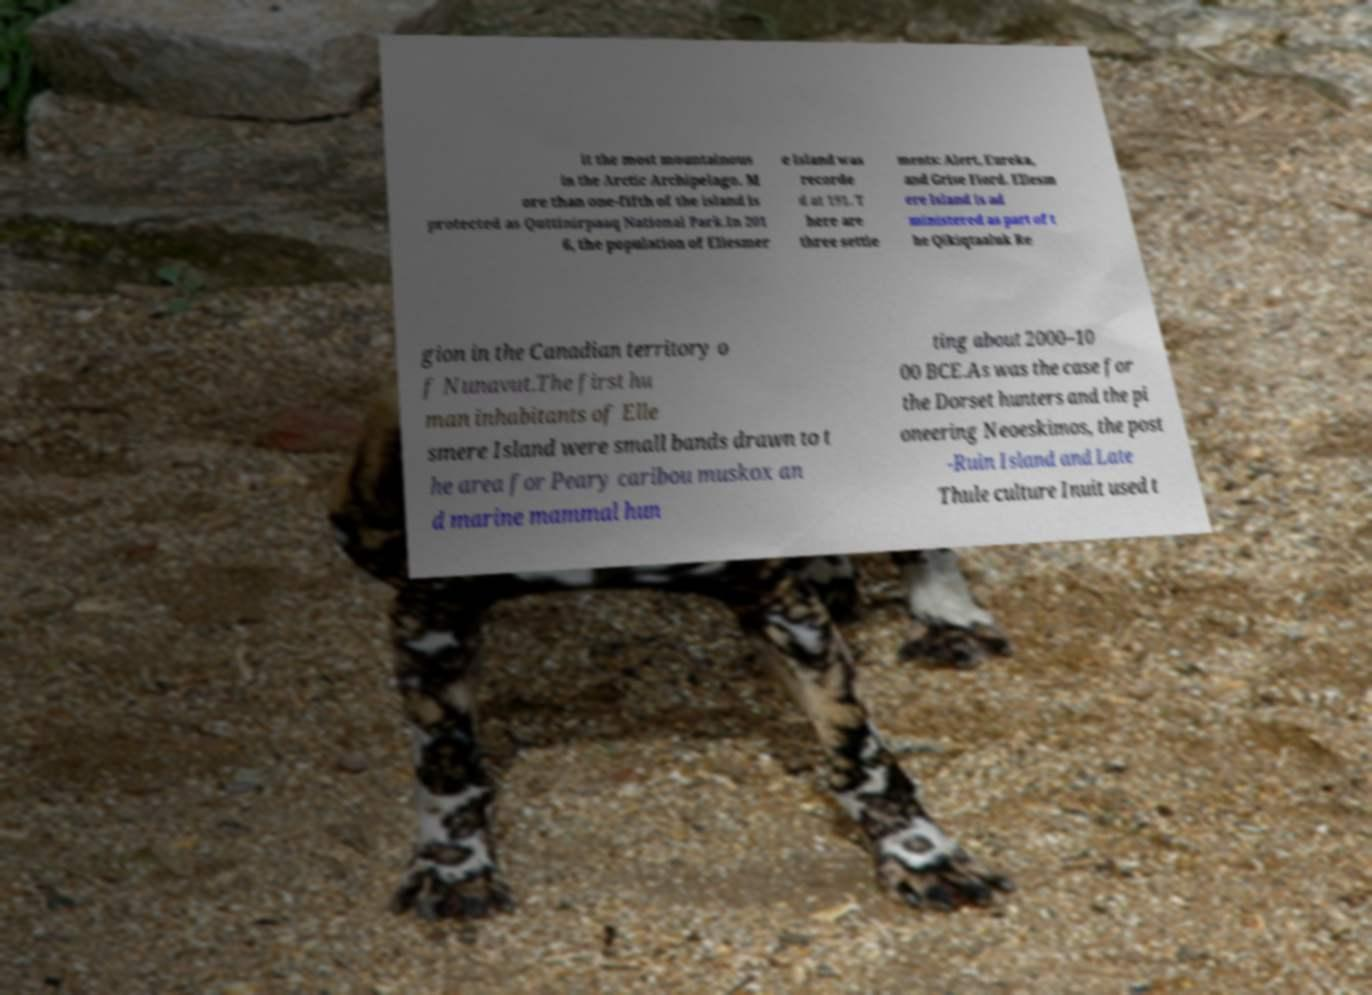Please identify and transcribe the text found in this image. it the most mountainous in the Arctic Archipelago. M ore than one-fifth of the island is protected as Quttinirpaaq National Park.In 201 6, the population of Ellesmer e Island was recorde d at 191. T here are three settle ments: Alert, Eureka, and Grise Fiord. Ellesm ere Island is ad ministered as part of t he Qikiqtaaluk Re gion in the Canadian territory o f Nunavut.The first hu man inhabitants of Elle smere Island were small bands drawn to t he area for Peary caribou muskox an d marine mammal hun ting about 2000–10 00 BCE.As was the case for the Dorset hunters and the pi oneering Neoeskimos, the post -Ruin Island and Late Thule culture Inuit used t 